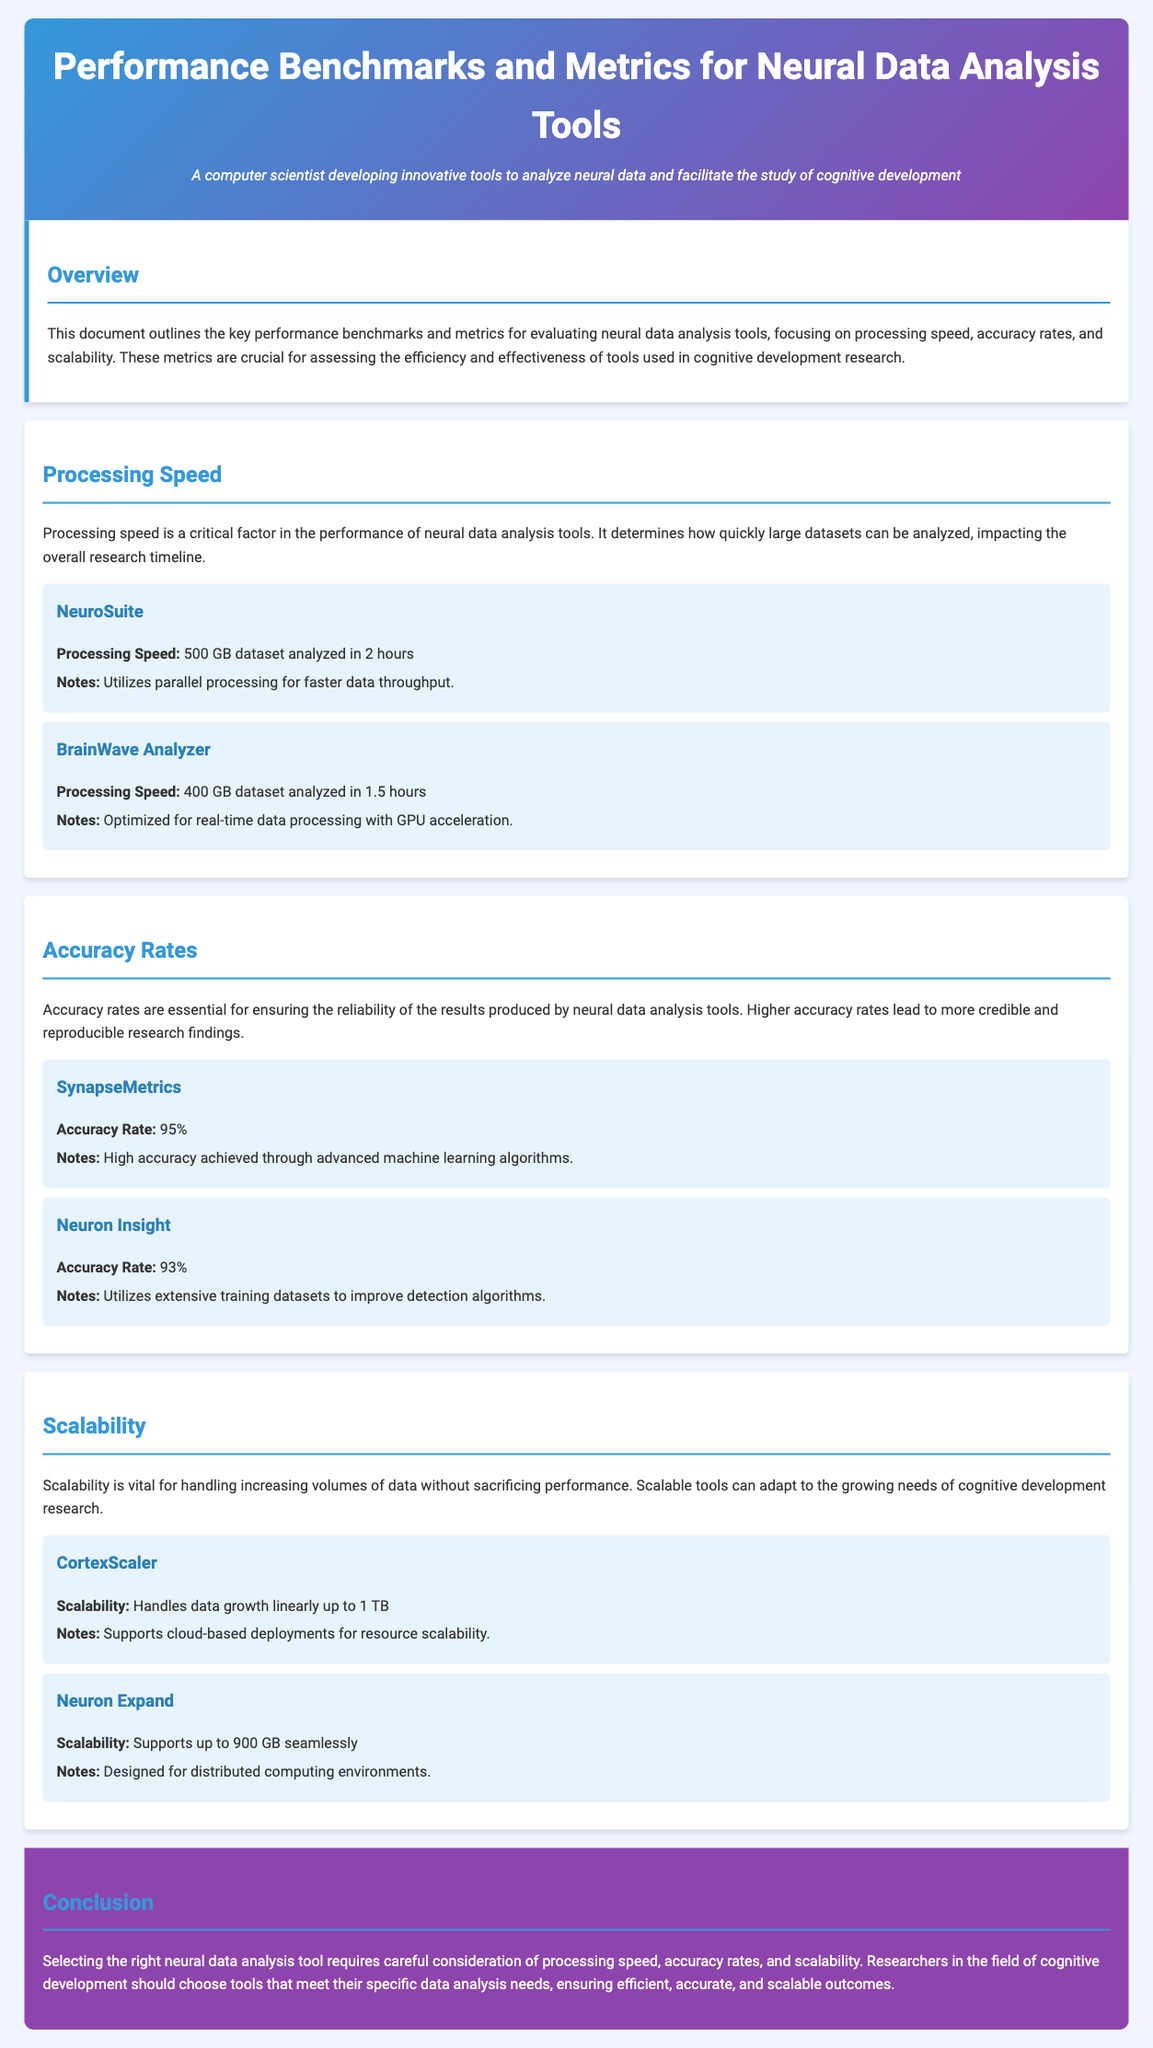What is the processing speed of NeuroSuite? NeuroSuite's processing speed is highlighted in the document, showing the time taken to analyze a specific dataset.
Answer: 500 GB dataset analyzed in 2 hours What accuracy rate does SynapseMetrics achieve? The document specifies the accuracy rate for SynapseMetrics, showing its efficiency in analysis.
Answer: 95% How much data can CortexScaler handle? The scalability capacity of CortexScaler is mentioned in the document, indicating its performance under data growth.
Answer: 1 TB What is the processing speed of BrainWave Analyzer? The processing speed for BrainWave Analyzer is detailed, showing its capability in analyzing datasets.
Answer: 400 GB dataset analyzed in 1.5 hours Which tool is optimized for real-time data processing? The document describes the features of each tool, indicating which one is designed for real-time analysis.
Answer: BrainWave Analyzer What is the accuracy rate of Neuron Insight? The accuracy rate for Neuron Insight is presented, reflecting its reliability in data analysis.
Answer: 93% How does CortexScaler support scalability? The document explains how CortexScaler enables scalability in data handling for cognitive research.
Answer: Cloud-based deployments What kind of algorithms does SynapseMetrics use for accuracy? The document describes the methods used by SynapseMetrics to achieve its accuracy rate.
Answer: Advanced machine learning algorithms How much data does Neuron Expand support? The scalability specifics of Neuron Expand are mentioned in the document, showing its upper limits.
Answer: 900 GB 